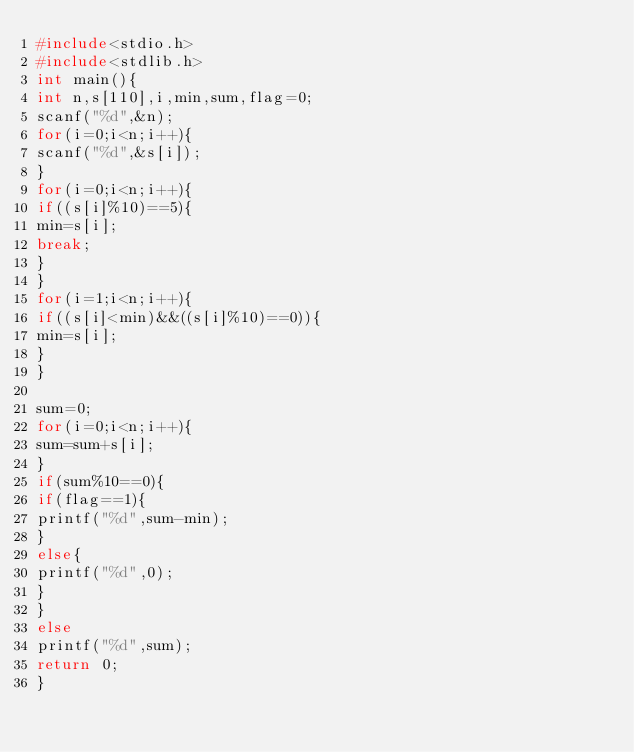<code> <loc_0><loc_0><loc_500><loc_500><_C_>#include<stdio.h>
#include<stdlib.h>
int main(){
int n,s[110],i,min,sum,flag=0;
scanf("%d",&n);
for(i=0;i<n;i++){
scanf("%d",&s[i]);
}
for(i=0;i<n;i++){
if((s[i]%10)==5){
min=s[i];
break;
}
}
for(i=1;i<n;i++){
if((s[i]<min)&&((s[i]%10)==0)){
min=s[i];
}
}

sum=0;
for(i=0;i<n;i++){
sum=sum+s[i];
}
if(sum%10==0){
if(flag==1){
printf("%d",sum-min);
}
else{
printf("%d",0);
}
}
else
printf("%d",sum);
return 0;
}</code> 